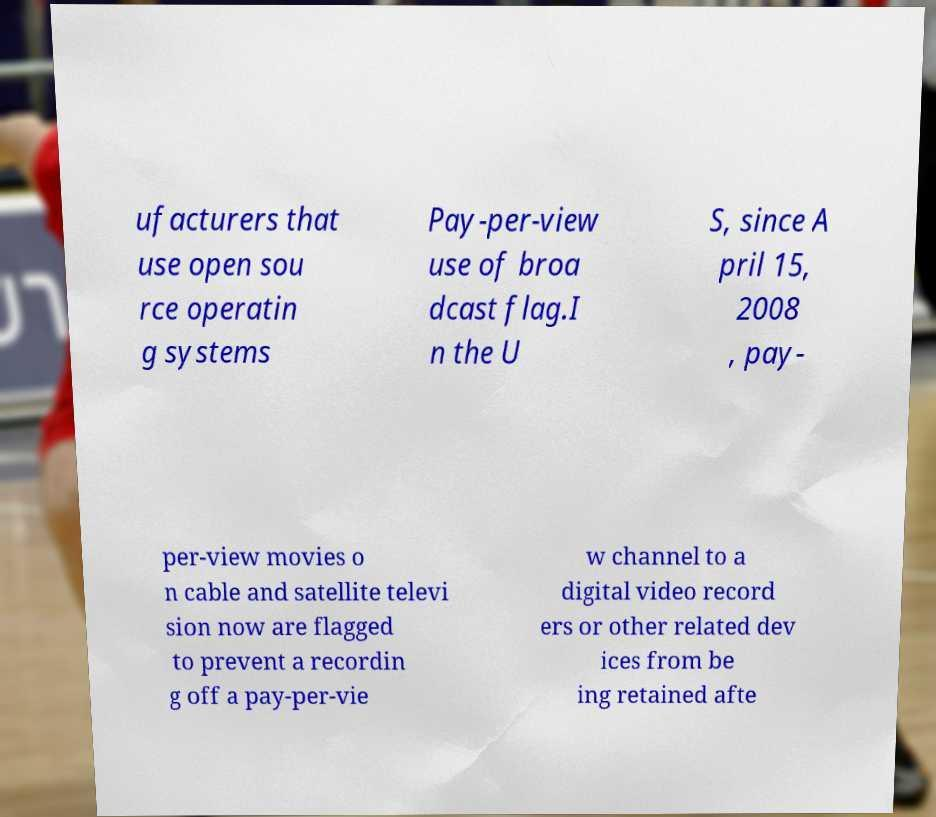Can you read and provide the text displayed in the image?This photo seems to have some interesting text. Can you extract and type it out for me? ufacturers that use open sou rce operatin g systems Pay-per-view use of broa dcast flag.I n the U S, since A pril 15, 2008 , pay- per-view movies o n cable and satellite televi sion now are flagged to prevent a recordin g off a pay-per-vie w channel to a digital video record ers or other related dev ices from be ing retained afte 